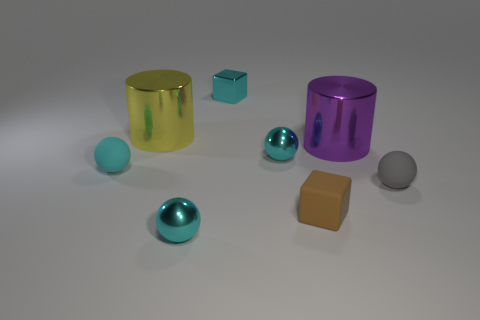There is a small rubber object that is the same color as the tiny metallic cube; what shape is it?
Ensure brevity in your answer.  Sphere. There is a rubber object left of the shiny object that is in front of the tiny gray matte sphere; are there any brown matte blocks that are behind it?
Your response must be concise. No. Do the tiny matte sphere on the left side of the tiny gray matte object and the tiny sphere behind the cyan rubber object have the same color?
Give a very brief answer. Yes. What material is the gray thing that is the same size as the metallic block?
Keep it short and to the point. Rubber. How big is the metal cylinder that is to the right of the large cylinder to the left of the small cyan metal ball behind the small brown block?
Ensure brevity in your answer.  Large. How many other things are the same material as the yellow cylinder?
Offer a very short reply. 4. How big is the cylinder that is on the left side of the cyan metallic cube?
Provide a short and direct response. Large. What number of shiny things are behind the large yellow object and in front of the big yellow metallic thing?
Make the answer very short. 0. There is a tiny cyan thing that is in front of the small thing that is on the left side of the yellow cylinder; what is its material?
Your response must be concise. Metal. What is the material of the yellow object that is the same shape as the purple object?
Provide a succinct answer. Metal. 